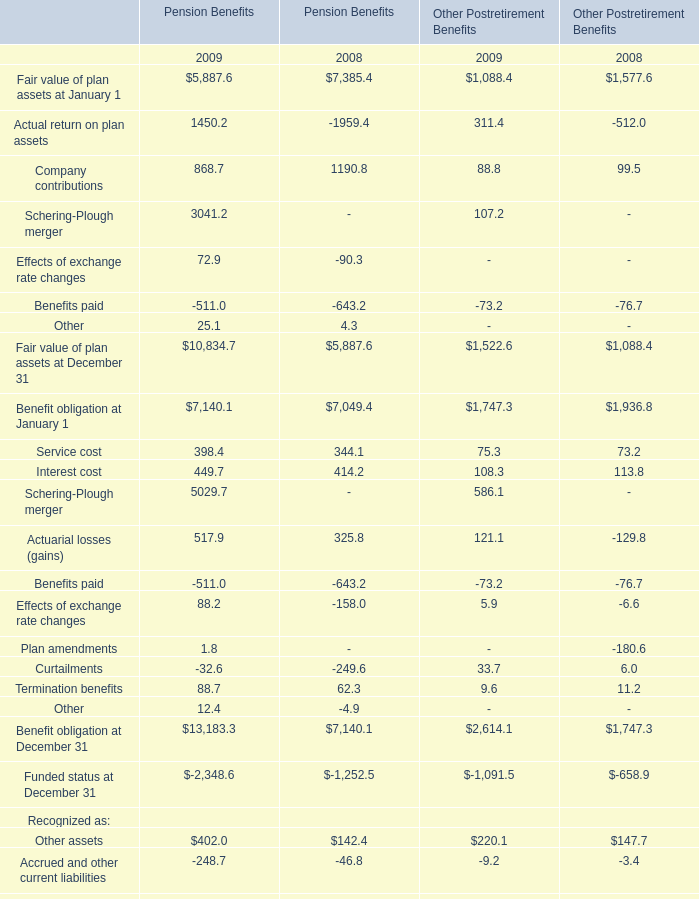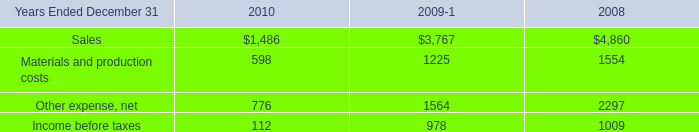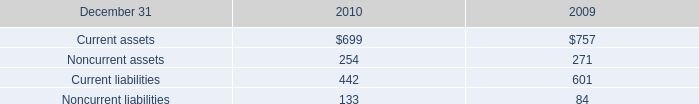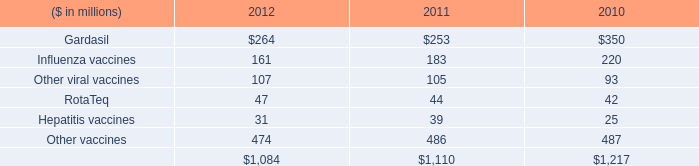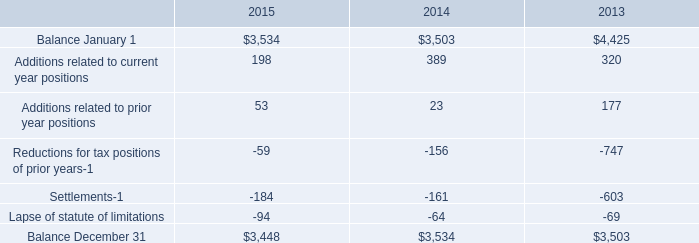What's the sum of Balance December 31 of 2014, and Benefit obligation at January 1 of Pension Benefits 2008 ? 
Computations: (3534.0 + 7049.4)
Answer: 10583.4. 